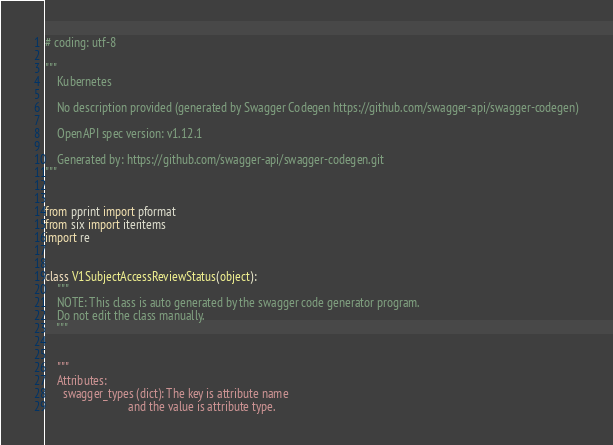Convert code to text. <code><loc_0><loc_0><loc_500><loc_500><_Python_># coding: utf-8

"""
    Kubernetes

    No description provided (generated by Swagger Codegen https://github.com/swagger-api/swagger-codegen)

    OpenAPI spec version: v1.12.1
    
    Generated by: https://github.com/swagger-api/swagger-codegen.git
"""


from pprint import pformat
from six import iteritems
import re


class V1SubjectAccessReviewStatus(object):
    """
    NOTE: This class is auto generated by the swagger code generator program.
    Do not edit the class manually.
    """


    """
    Attributes:
      swagger_types (dict): The key is attribute name
                            and the value is attribute type.</code> 